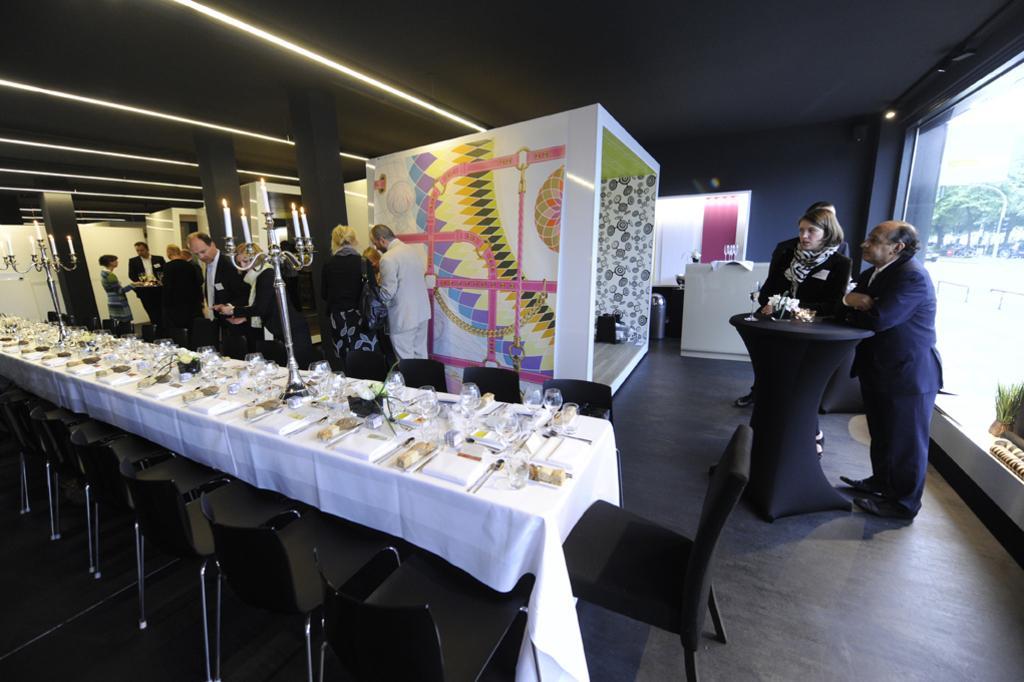How would you summarize this image in a sentence or two? Group of people are standing at a party in a hall. 